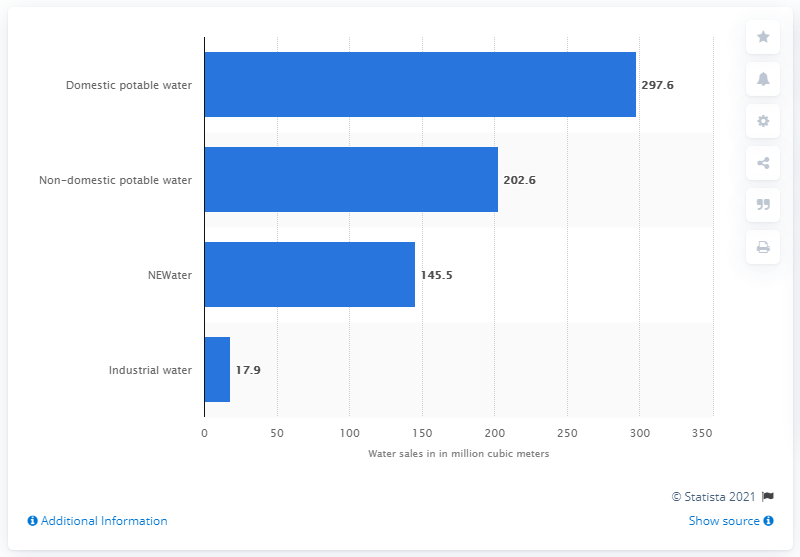Specify some key components in this picture. In 2019, a total of 145.5 cubic meters of NEWater was sold in Singapore. In 2019, a total of 297.6 million cubic meters of domestic potable water was sold in Singapore. 